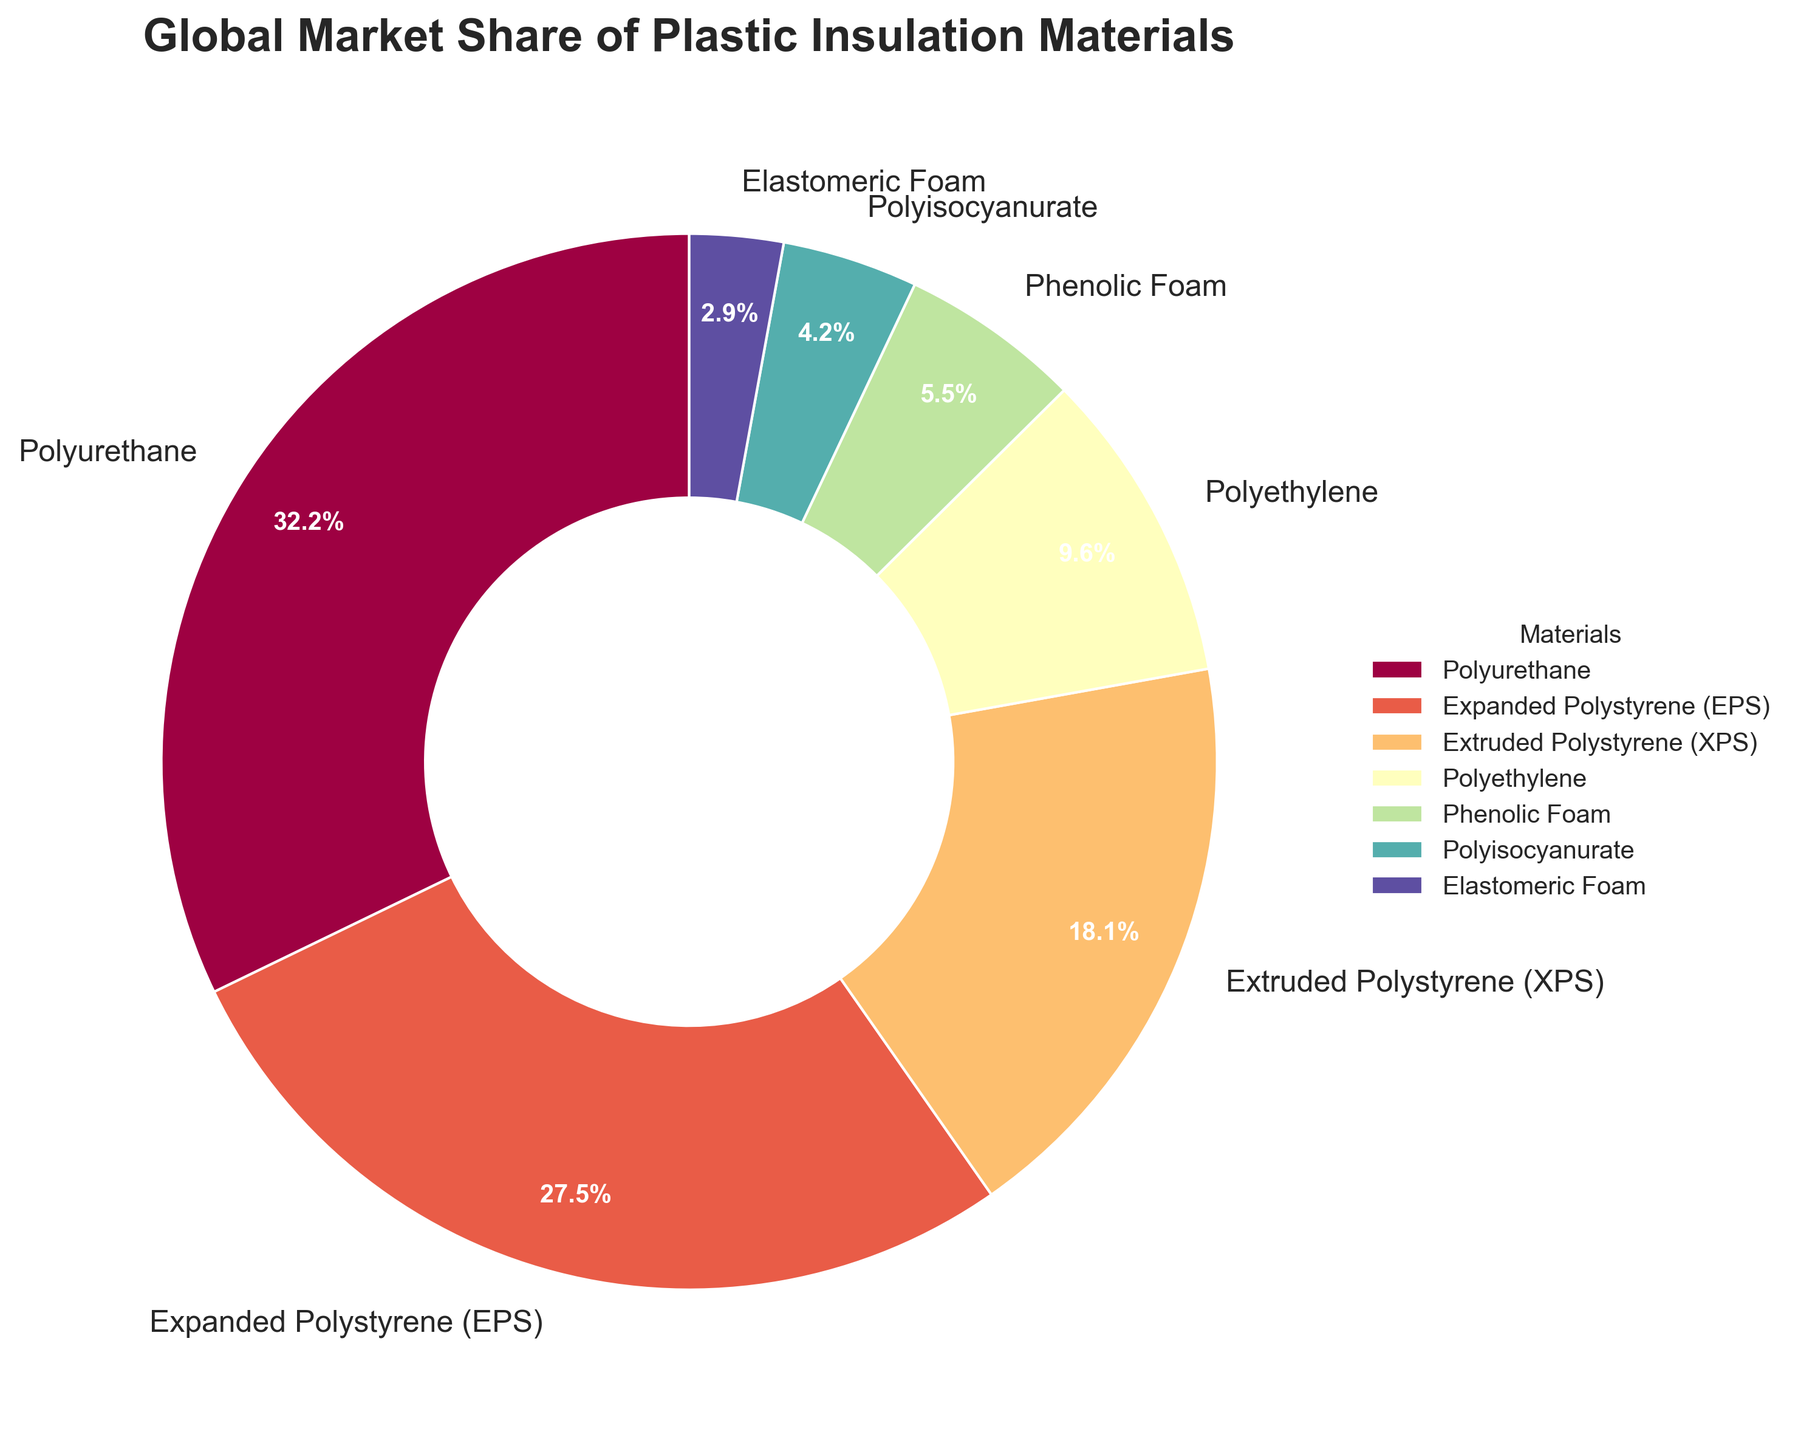What is the market share of Polyurethane? Look for the Polyurethane section in the pie chart and note its market share percentage as shown in the figure.
Answer: 32.5% What is the combined market share of Expanded Polystyrene (EPS) and Extruded Polystyrene (XPS)? Identify the percentage values for both Expanded Polystyrene (EPS) and Extruded Polystyrene (XPS) from the figure and add them together: 27.8% + 18.3% = 46.1%.
Answer: 46.1% Which material has the smallest market share and how much is it? Locate the section with the smallest market share in the pie chart; it is Elastomeric Foam with 2.9%.
Answer: Elastomeric Foam, 2.9% Is the market share of Polyurethane greater than the combined market shares of Polyisocyanurate and Elastomeric Foam? Compare the market share of Polyurethane (32.5%) to the sum of the market shares of Polyisocyanurate and Elastomeric Foam (4.2% + 2.9% = 7.1%). Since 32.5% is greater than 7.1%, the answer is yes.
Answer: Yes How many materials have a market share greater than 10%? Count the materials in the pie chart sections that have a market share above 10%: Polyurethane (32.5%), Expanded Polystyrene (EPS) (27.8%), and Extruded Polystyrene (XPS) (18.3%). This gives us a total of 3 materials.
Answer: 3 Which material has a market share closest to 5%? Check each material's market share to find the one closest to 5%: Phenolic Foam has a market share of 5.6%, which is closest to 5%.
Answer: Phenolic Foam What is the average market share of Polyethylene and Phenolic Foam? Add the market shares of Polyethylene and Phenolic Foam, then divide by 2: (9.7% + 5.6%) / 2 = 7.65%.
Answer: 7.65% Which material has a larger market share, Polyisocyanurate or Phenolic Foam? Compare the market shares of Polyisocyanurate (4.2%) and Phenolic Foam (5.6%). Phenolic Foam is larger.
Answer: Phenolic Foam What fraction of the market share does Elastomeric Foam represent? Divide the market share of Elastomeric Foam by 100 to convert it into a fraction: 2.9% / 100 = 0.029.
Answer: 0.029 If the market share of Polyurethane increased by 2%, what would its new market share be? Add 2% to the current market share of Polyurethane: 32.5% + 2% = 34.5%.
Answer: 34.5% 